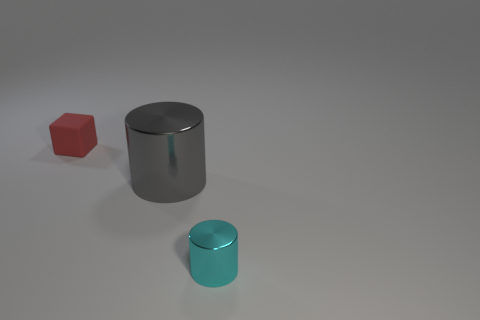How many cylinders are either gray things or green things?
Your answer should be compact. 1. What number of gray objects are in front of the object that is to the left of the large shiny cylinder?
Your response must be concise. 1. Is the material of the big gray object the same as the tiny block?
Provide a succinct answer. No. Are there any cyan things that have the same material as the small red block?
Provide a succinct answer. No. There is a cylinder behind the small thing to the right of the small object behind the tiny cyan object; what color is it?
Offer a very short reply. Gray. How many cyan things are either large cylinders or rubber objects?
Offer a very short reply. 0. How many tiny cyan things have the same shape as the red matte object?
Your answer should be very brief. 0. The cyan shiny object that is the same size as the matte cube is what shape?
Make the answer very short. Cylinder. Are there any cylinders behind the cyan metal cylinder?
Make the answer very short. Yes. Are there any things that are behind the cylinder that is in front of the large metallic object?
Ensure brevity in your answer.  Yes. 